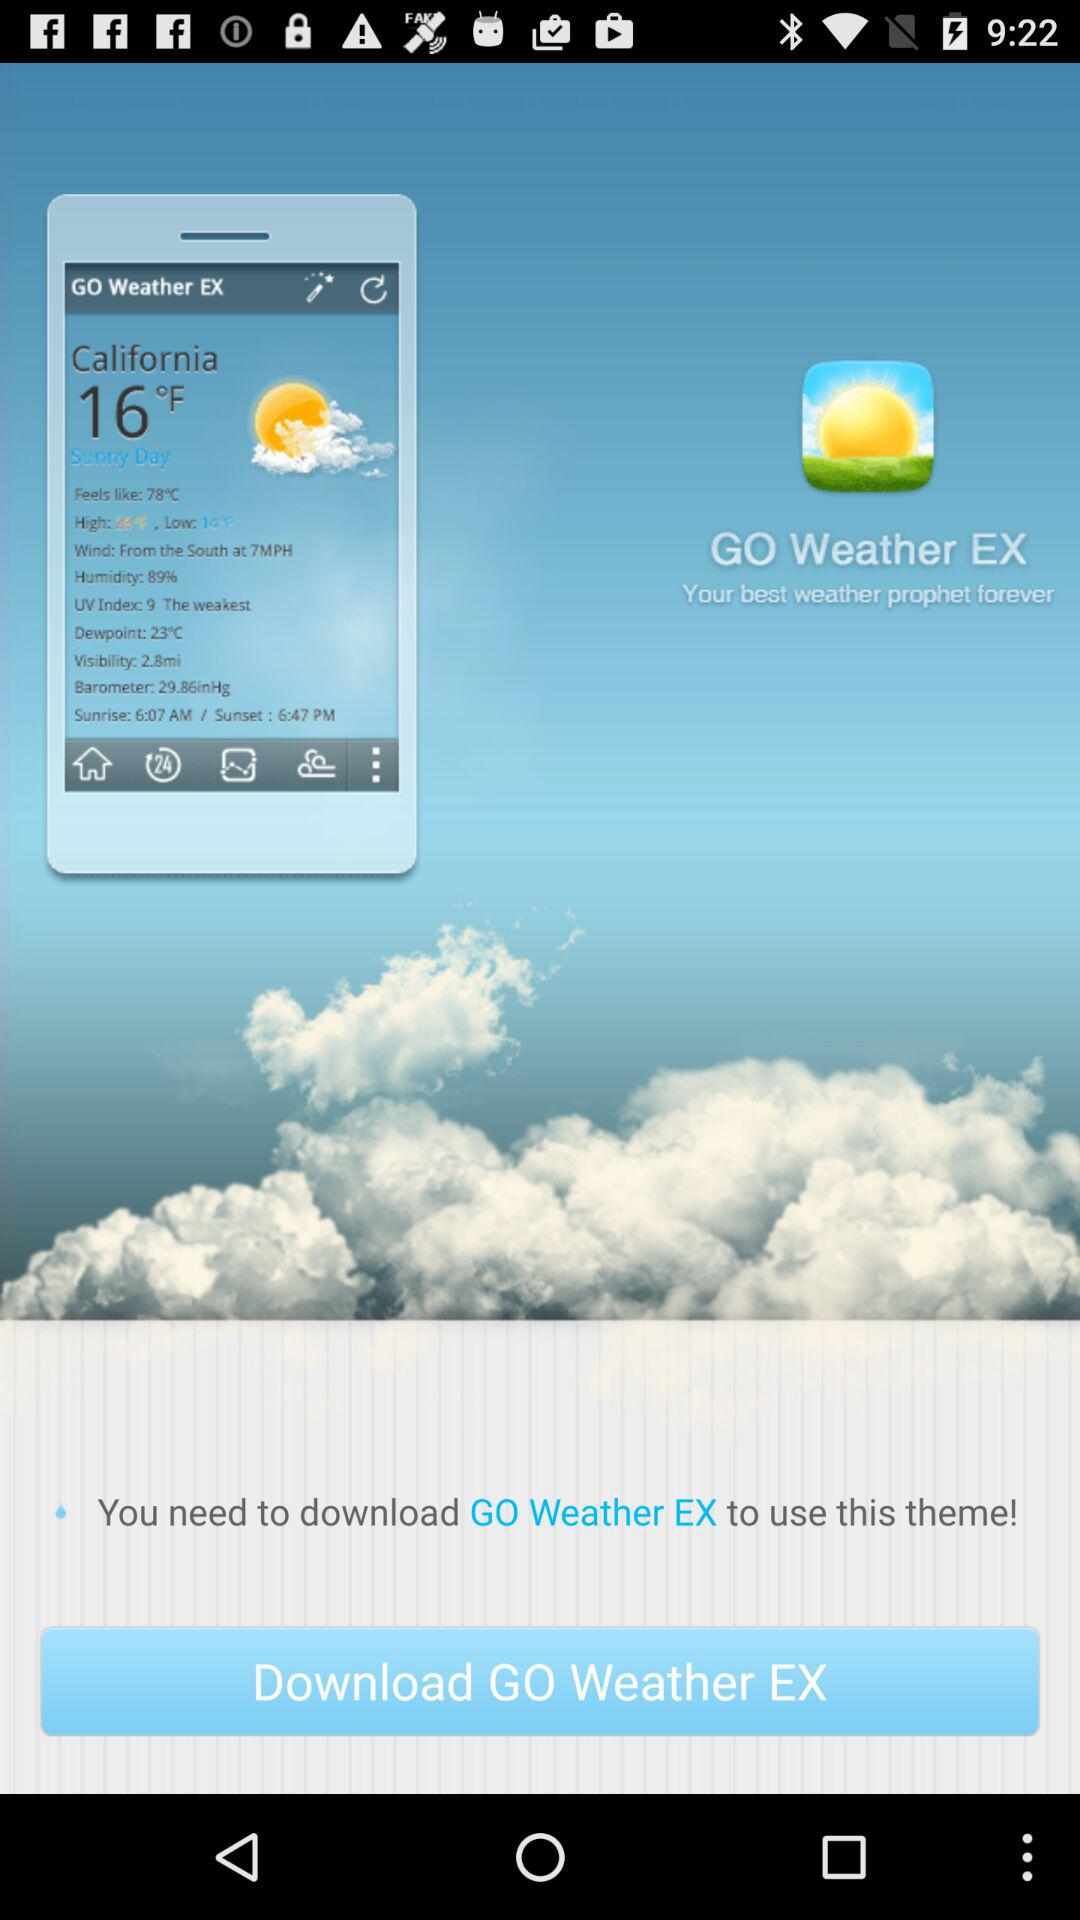What app do you need to download to use this theme? The app is "GO Weather EX". 